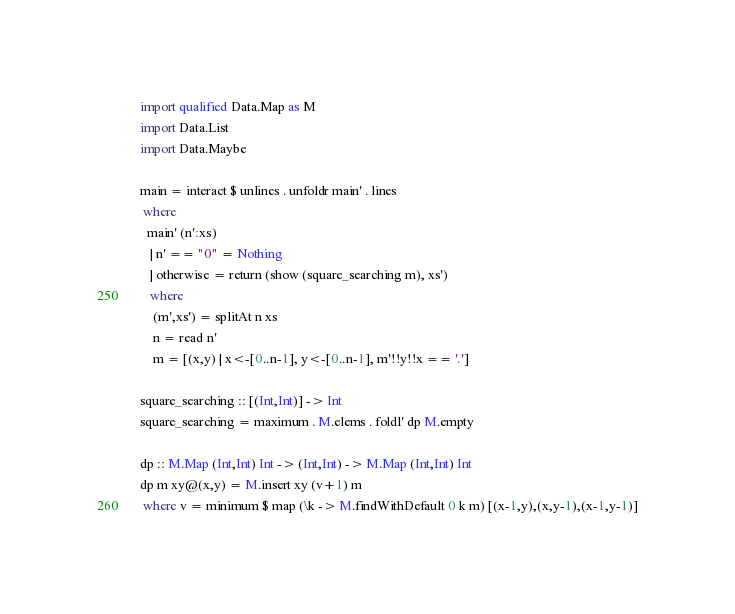<code> <loc_0><loc_0><loc_500><loc_500><_Haskell_>import qualified Data.Map as M
import Data.List
import Data.Maybe

main = interact $ unlines . unfoldr main' . lines
 where
  main' (n':xs)
   | n' == "0" = Nothing
   | otherwise = return (show (square_searching m), xs')
   where
    (m',xs') = splitAt n xs
    n = read n'
    m = [(x,y) | x<-[0..n-1], y<-[0..n-1], m'!!y!!x == '.']

square_searching :: [(Int,Int)] -> Int
square_searching = maximum . M.elems . foldl' dp M.empty

dp :: M.Map (Int,Int) Int -> (Int,Int) -> M.Map (Int,Int) Int
dp m xy@(x,y) = M.insert xy (v+1) m
 where v = minimum $ map (\k -> M.findWithDefault 0 k m) [(x-1,y),(x,y-1),(x-1,y-1)]</code> 